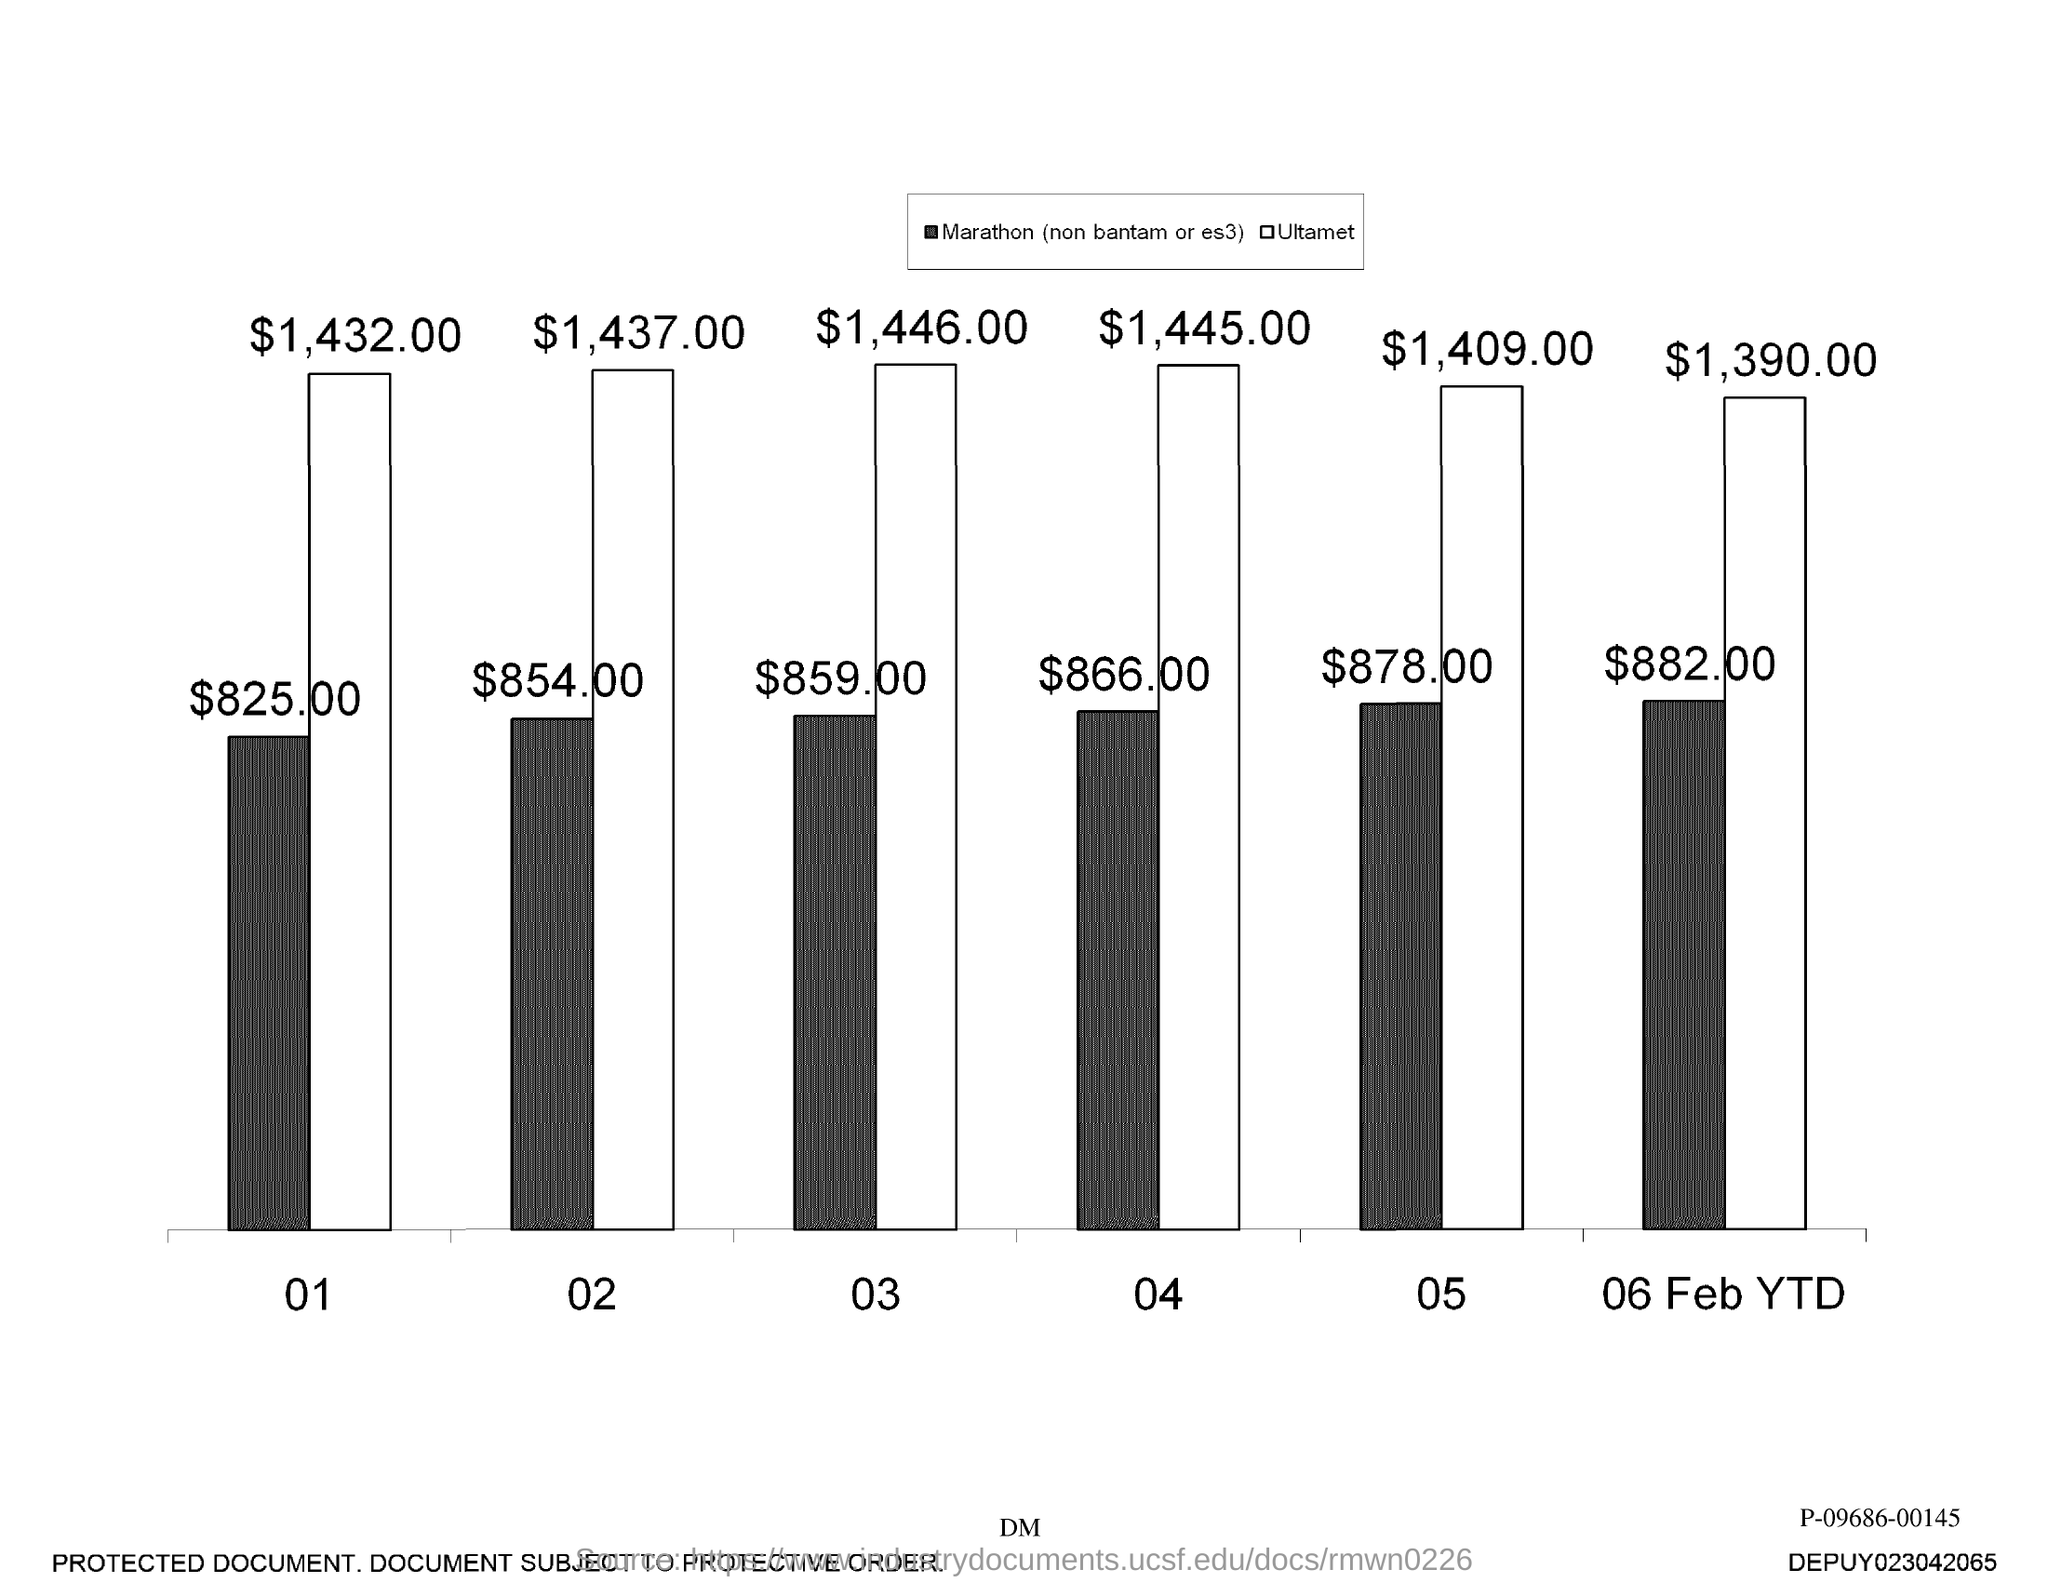Indicate a few pertinent items in this graphic. The highest value in the graph is $1,446.00. 